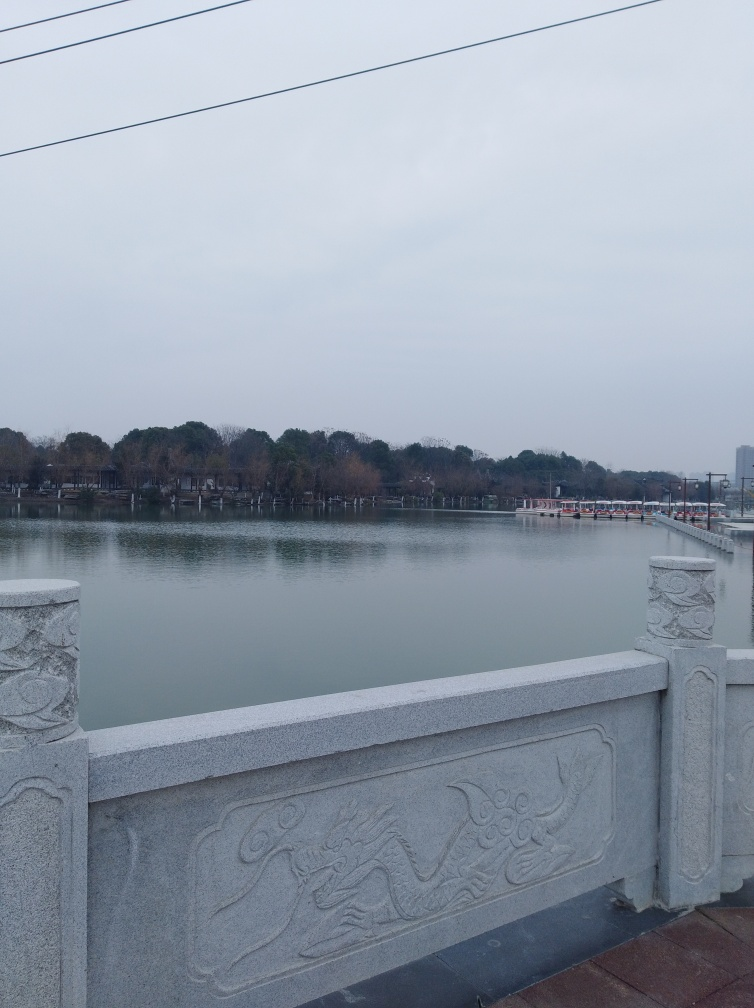Can you speculate about the location or cultural significance of the setting in this image? Given the style of the balustrade, which is decorated with relief carvings that appear to be dragons, the location might be in East Asia, possibly China or a neighboring country with cultural overlap. Dragons are often used in architecture to signify power and good fortune. 